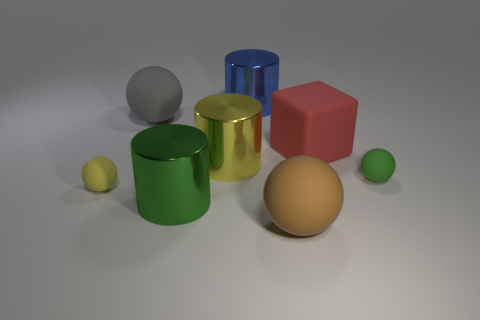There is a sphere that is both in front of the gray rubber sphere and left of the large brown rubber thing; what is its color?
Offer a terse response. Yellow. Is there any other thing that has the same material as the tiny green ball?
Make the answer very short. Yes. Is the red object made of the same material as the big ball that is behind the yellow matte sphere?
Make the answer very short. Yes. There is a cylinder that is behind the large sphere that is left of the blue cylinder; how big is it?
Offer a terse response. Large. Are there any other things that are the same color as the big rubber block?
Give a very brief answer. No. Are the tiny thing left of the big blue shiny cylinder and the large sphere in front of the rubber cube made of the same material?
Ensure brevity in your answer.  Yes. What is the material of the thing that is on the left side of the blue cylinder and in front of the yellow rubber object?
Your answer should be compact. Metal. Does the red rubber object have the same shape as the green rubber object that is in front of the large yellow shiny cylinder?
Keep it short and to the point. No. There is a yellow object that is to the left of the large rubber object left of the large sphere in front of the red matte block; what is it made of?
Offer a terse response. Rubber. How many other things are there of the same size as the gray rubber ball?
Give a very brief answer. 5. 